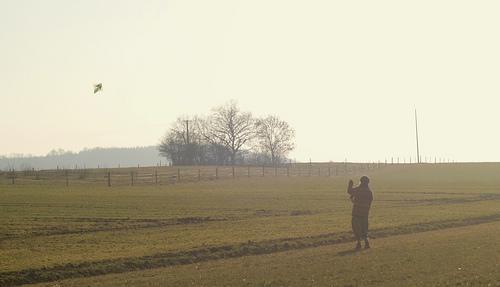How many people flying kites?
Give a very brief answer. 1. 